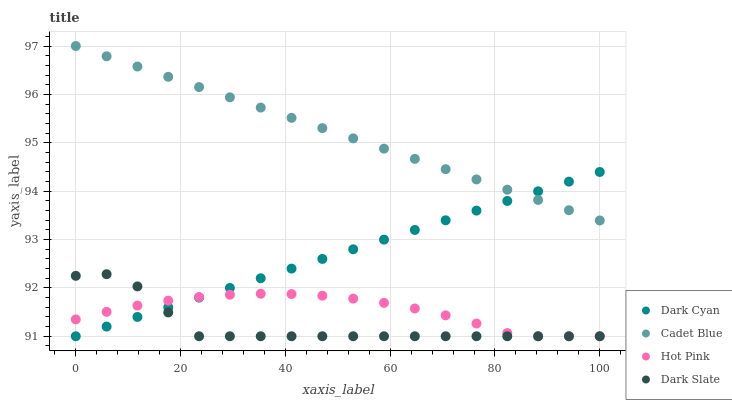Does Dark Slate have the minimum area under the curve?
Answer yes or no. Yes. Does Cadet Blue have the maximum area under the curve?
Answer yes or no. Yes. Does Cadet Blue have the minimum area under the curve?
Answer yes or no. No. Does Dark Slate have the maximum area under the curve?
Answer yes or no. No. Is Cadet Blue the smoothest?
Answer yes or no. Yes. Is Dark Slate the roughest?
Answer yes or no. Yes. Is Dark Slate the smoothest?
Answer yes or no. No. Is Cadet Blue the roughest?
Answer yes or no. No. Does Dark Cyan have the lowest value?
Answer yes or no. Yes. Does Cadet Blue have the lowest value?
Answer yes or no. No. Does Cadet Blue have the highest value?
Answer yes or no. Yes. Does Dark Slate have the highest value?
Answer yes or no. No. Is Hot Pink less than Cadet Blue?
Answer yes or no. Yes. Is Cadet Blue greater than Dark Slate?
Answer yes or no. Yes. Does Hot Pink intersect Dark Cyan?
Answer yes or no. Yes. Is Hot Pink less than Dark Cyan?
Answer yes or no. No. Is Hot Pink greater than Dark Cyan?
Answer yes or no. No. Does Hot Pink intersect Cadet Blue?
Answer yes or no. No. 